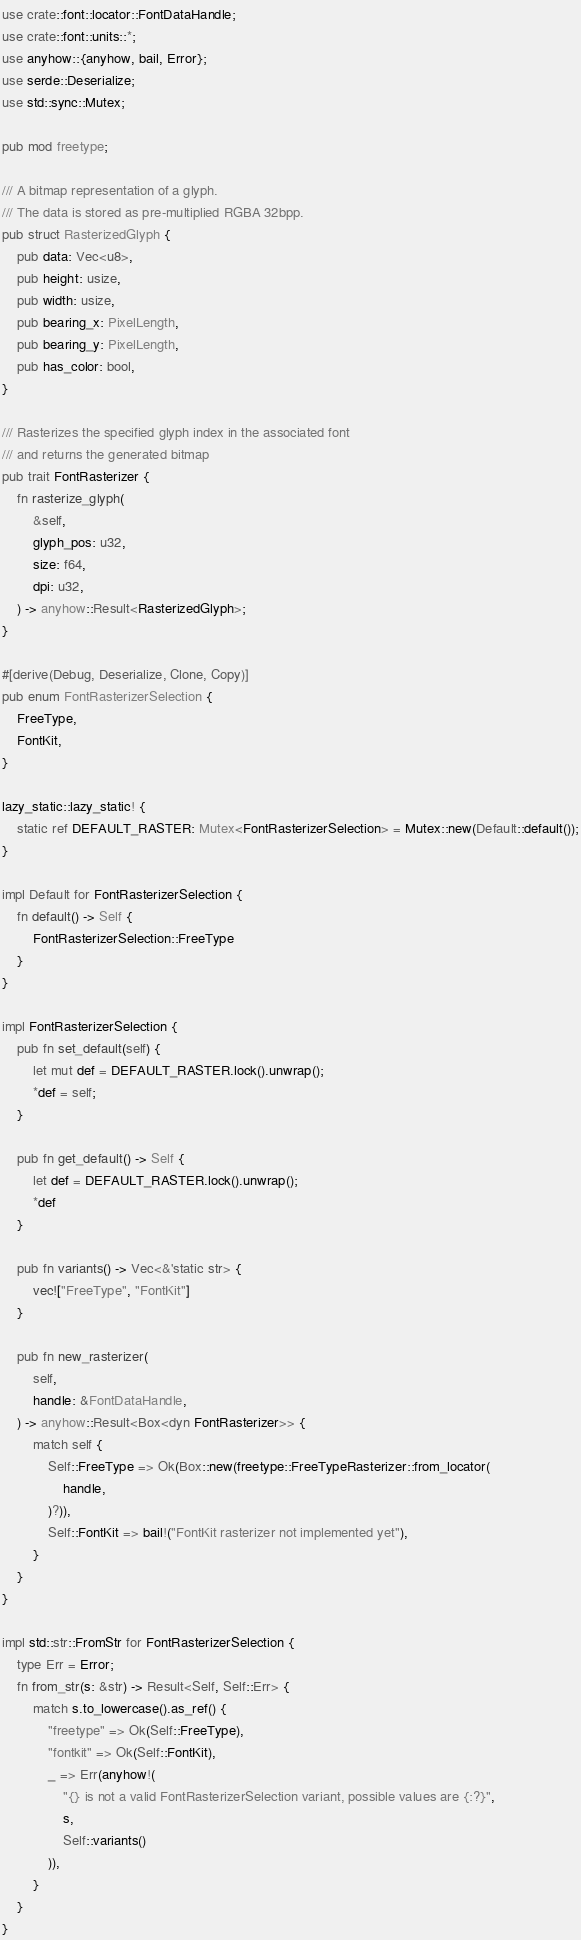<code> <loc_0><loc_0><loc_500><loc_500><_Rust_>use crate::font::locator::FontDataHandle;
use crate::font::units::*;
use anyhow::{anyhow, bail, Error};
use serde::Deserialize;
use std::sync::Mutex;

pub mod freetype;

/// A bitmap representation of a glyph.
/// The data is stored as pre-multiplied RGBA 32bpp.
pub struct RasterizedGlyph {
    pub data: Vec<u8>,
    pub height: usize,
    pub width: usize,
    pub bearing_x: PixelLength,
    pub bearing_y: PixelLength,
    pub has_color: bool,
}

/// Rasterizes the specified glyph index in the associated font
/// and returns the generated bitmap
pub trait FontRasterizer {
    fn rasterize_glyph(
        &self,
        glyph_pos: u32,
        size: f64,
        dpi: u32,
    ) -> anyhow::Result<RasterizedGlyph>;
}

#[derive(Debug, Deserialize, Clone, Copy)]
pub enum FontRasterizerSelection {
    FreeType,
    FontKit,
}

lazy_static::lazy_static! {
    static ref DEFAULT_RASTER: Mutex<FontRasterizerSelection> = Mutex::new(Default::default());
}

impl Default for FontRasterizerSelection {
    fn default() -> Self {
        FontRasterizerSelection::FreeType
    }
}

impl FontRasterizerSelection {
    pub fn set_default(self) {
        let mut def = DEFAULT_RASTER.lock().unwrap();
        *def = self;
    }

    pub fn get_default() -> Self {
        let def = DEFAULT_RASTER.lock().unwrap();
        *def
    }

    pub fn variants() -> Vec<&'static str> {
        vec!["FreeType", "FontKit"]
    }

    pub fn new_rasterizer(
        self,
        handle: &FontDataHandle,
    ) -> anyhow::Result<Box<dyn FontRasterizer>> {
        match self {
            Self::FreeType => Ok(Box::new(freetype::FreeTypeRasterizer::from_locator(
                handle,
            )?)),
            Self::FontKit => bail!("FontKit rasterizer not implemented yet"),
        }
    }
}

impl std::str::FromStr for FontRasterizerSelection {
    type Err = Error;
    fn from_str(s: &str) -> Result<Self, Self::Err> {
        match s.to_lowercase().as_ref() {
            "freetype" => Ok(Self::FreeType),
            "fontkit" => Ok(Self::FontKit),
            _ => Err(anyhow!(
                "{} is not a valid FontRasterizerSelection variant, possible values are {:?}",
                s,
                Self::variants()
            )),
        }
    }
}
</code> 